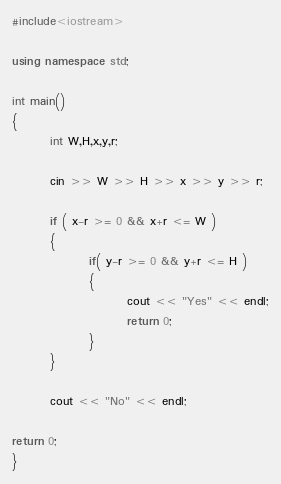<code> <loc_0><loc_0><loc_500><loc_500><_C++_>#include<iostream>

using namespace std;

int main()
{
        int W,H,x,y,r;

        cin >> W >> H >> x >> y >> r;

        if ( x-r >= 0 && x+r <= W )
        {
                if( y-r >= 0 && y+r <= H )
                {
                        cout << "Yes" << endl;
                        return 0;
                }
        }

        cout << "No" << endl;

return 0;
}

</code> 